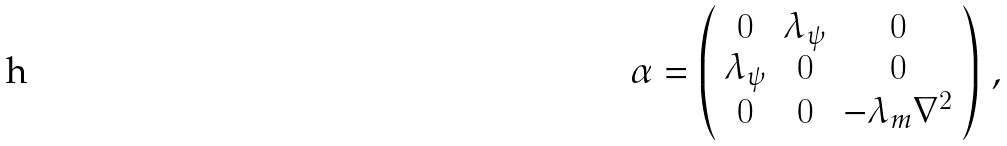Convert formula to latex. <formula><loc_0><loc_0><loc_500><loc_500>\alpha = \left ( \begin{array} { c c c } 0 & \lambda _ { \psi } & 0 \\ \lambda _ { \psi } & 0 & 0 \\ 0 & 0 & - \lambda _ { m } \nabla ^ { 2 } \end{array} \right ) \, ,</formula> 